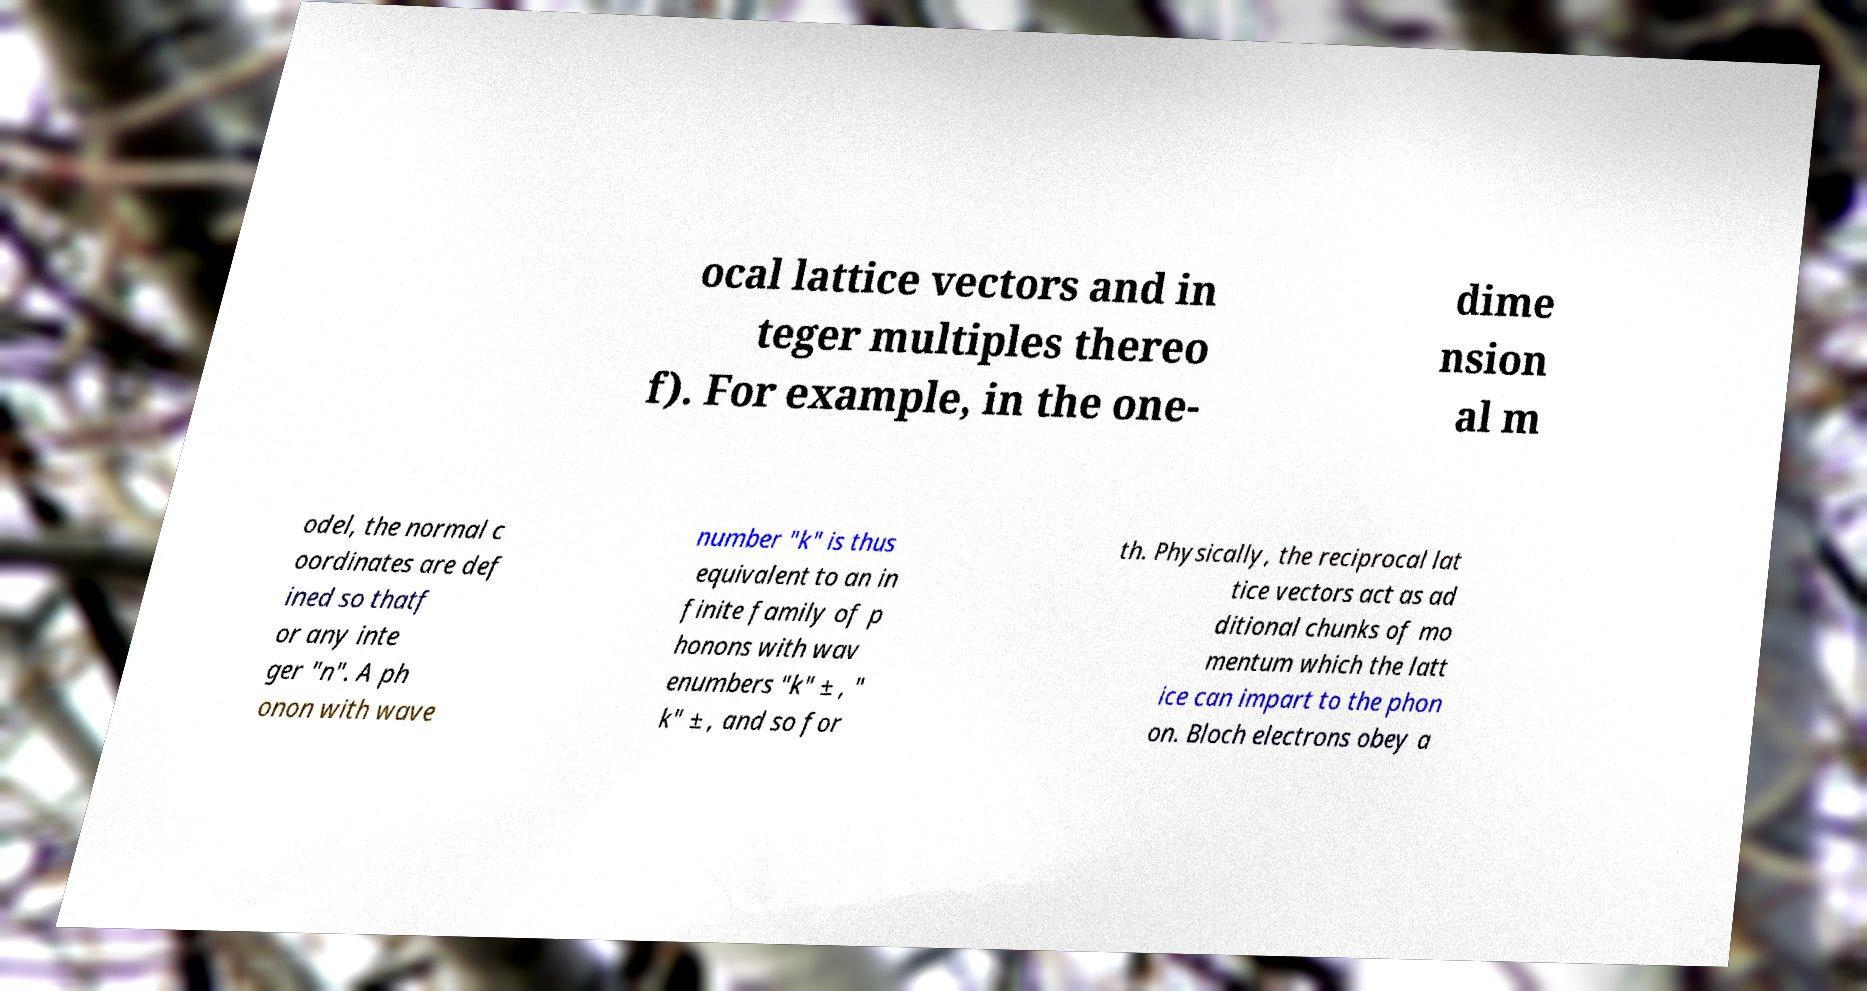What messages or text are displayed in this image? I need them in a readable, typed format. ocal lattice vectors and in teger multiples thereo f). For example, in the one- dime nsion al m odel, the normal c oordinates are def ined so thatf or any inte ger "n". A ph onon with wave number "k" is thus equivalent to an in finite family of p honons with wav enumbers "k" ± , " k" ± , and so for th. Physically, the reciprocal lat tice vectors act as ad ditional chunks of mo mentum which the latt ice can impart to the phon on. Bloch electrons obey a 